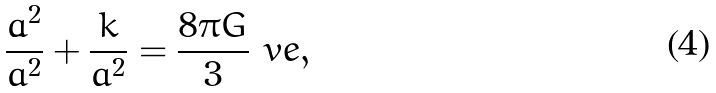<formula> <loc_0><loc_0><loc_500><loc_500>\frac { \dot { a } ^ { 2 } } { a ^ { 2 } } + \frac { k } { a ^ { 2 } } = \frac { 8 \pi G } { 3 } \ v e ,</formula> 